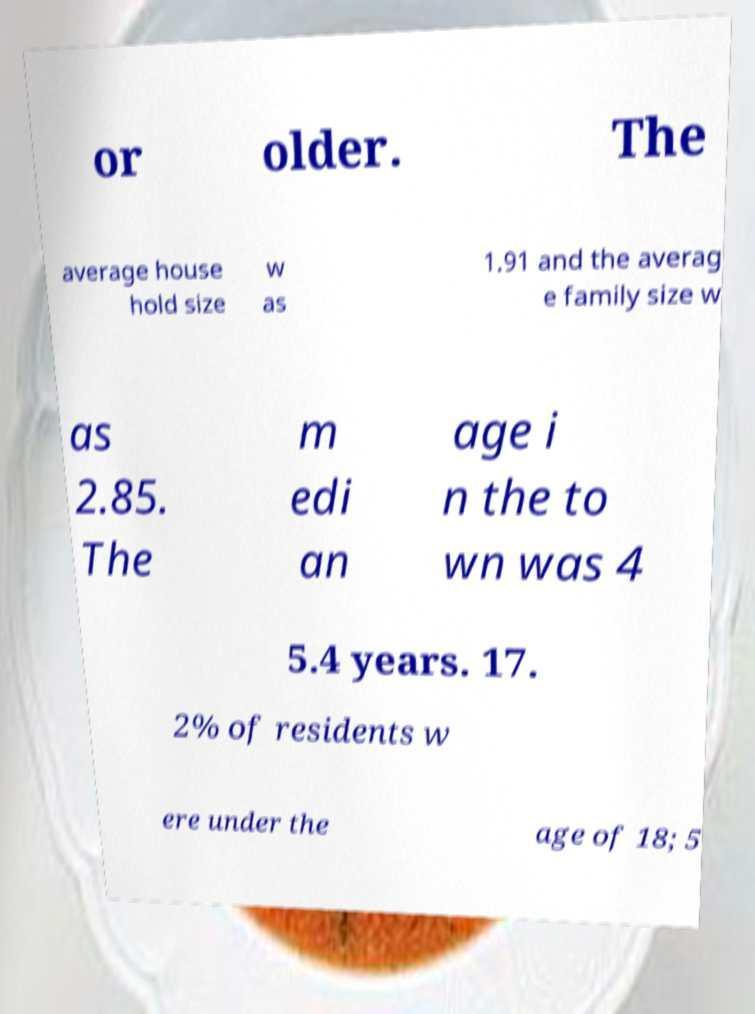Can you accurately transcribe the text from the provided image for me? or older. The average house hold size w as 1.91 and the averag e family size w as 2.85. The m edi an age i n the to wn was 4 5.4 years. 17. 2% of residents w ere under the age of 18; 5 